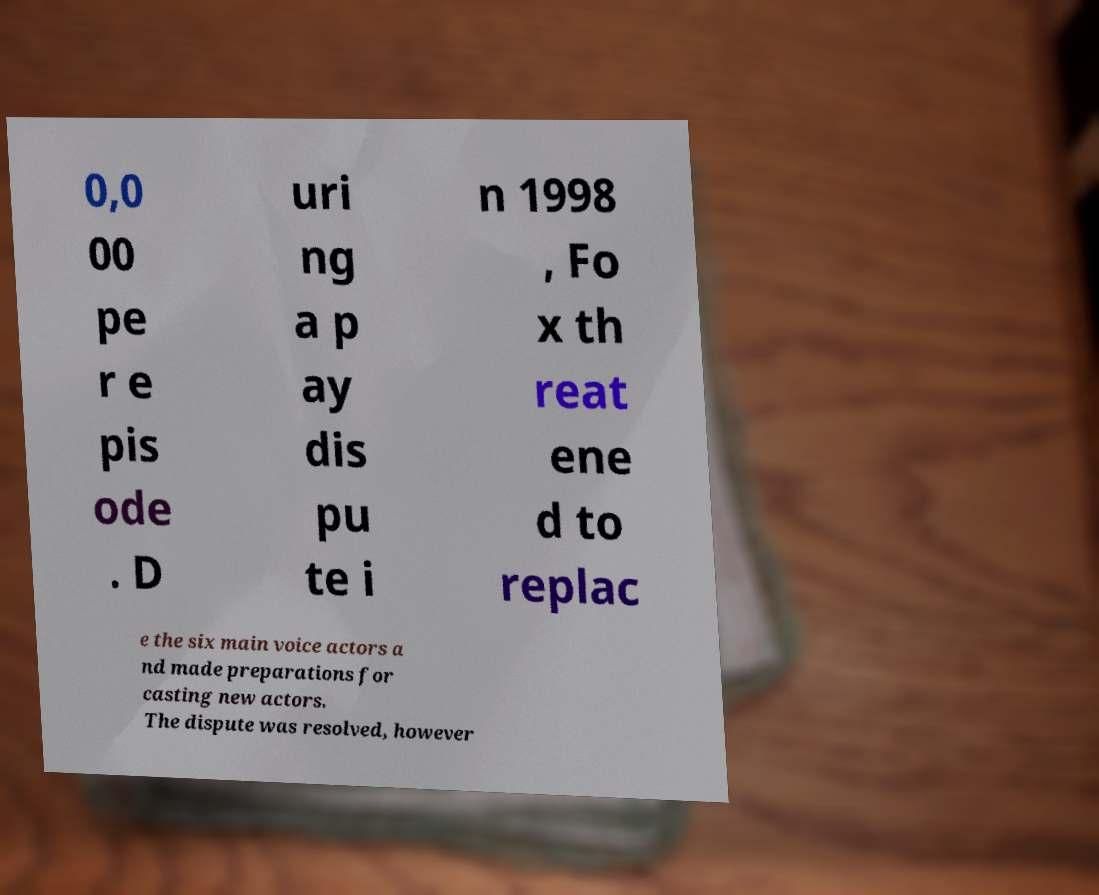What messages or text are displayed in this image? I need them in a readable, typed format. 0,0 00 pe r e pis ode . D uri ng a p ay dis pu te i n 1998 , Fo x th reat ene d to replac e the six main voice actors a nd made preparations for casting new actors. The dispute was resolved, however 